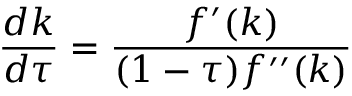<formula> <loc_0><loc_0><loc_500><loc_500>{ \frac { d k } { d \tau } } = { \frac { f ^ { \prime } ( k ) } { ( 1 - \tau ) f ^ { \prime \prime } ( k ) } }</formula> 